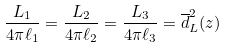<formula> <loc_0><loc_0><loc_500><loc_500>\frac { L _ { 1 } } { 4 \pi \ell _ { 1 } } = \frac { L _ { 2 } } { 4 \pi \ell _ { 2 } } = \frac { L _ { 3 } } { 4 \pi \ell _ { 3 } } = \overline { d } _ { L } ^ { 2 } ( z )</formula> 